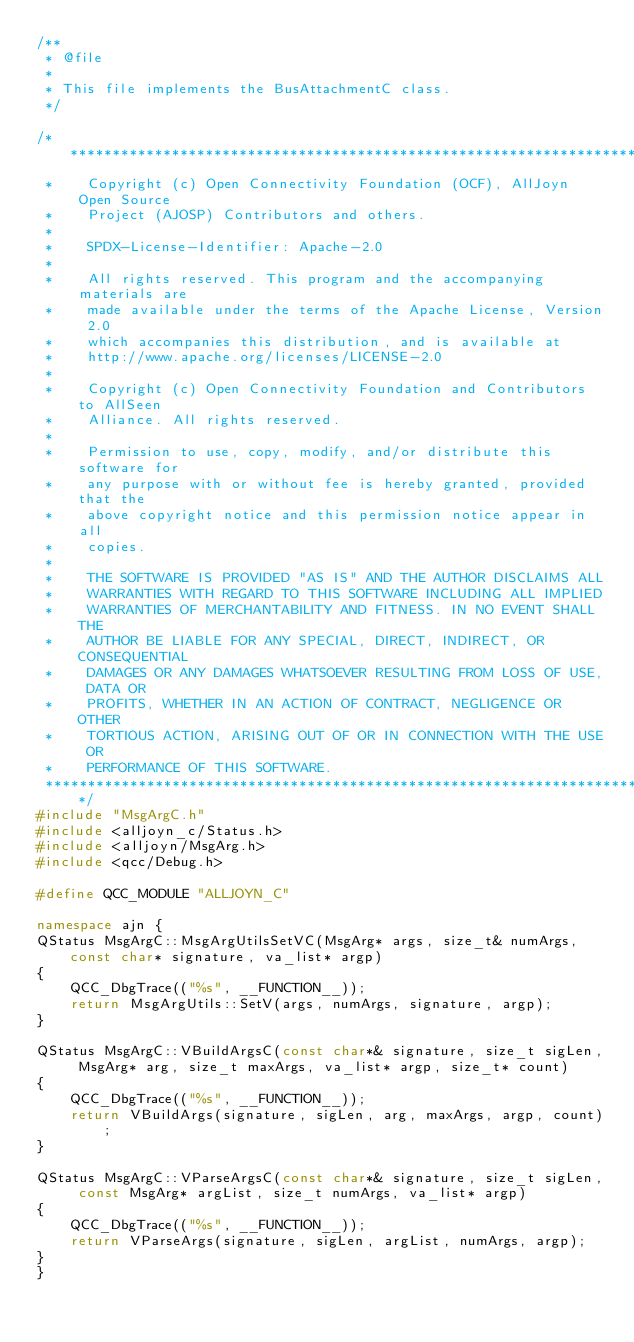<code> <loc_0><loc_0><loc_500><loc_500><_C++_>/**
 * @file
 *
 * This file implements the BusAttachmentC class.
 */

/******************************************************************************
 *    Copyright (c) Open Connectivity Foundation (OCF), AllJoyn Open Source
 *    Project (AJOSP) Contributors and others.
 *
 *    SPDX-License-Identifier: Apache-2.0
 *
 *    All rights reserved. This program and the accompanying materials are
 *    made available under the terms of the Apache License, Version 2.0
 *    which accompanies this distribution, and is available at
 *    http://www.apache.org/licenses/LICENSE-2.0
 *
 *    Copyright (c) Open Connectivity Foundation and Contributors to AllSeen
 *    Alliance. All rights reserved.
 *
 *    Permission to use, copy, modify, and/or distribute this software for
 *    any purpose with or without fee is hereby granted, provided that the
 *    above copyright notice and this permission notice appear in all
 *    copies.
 *
 *    THE SOFTWARE IS PROVIDED "AS IS" AND THE AUTHOR DISCLAIMS ALL
 *    WARRANTIES WITH REGARD TO THIS SOFTWARE INCLUDING ALL IMPLIED
 *    WARRANTIES OF MERCHANTABILITY AND FITNESS. IN NO EVENT SHALL THE
 *    AUTHOR BE LIABLE FOR ANY SPECIAL, DIRECT, INDIRECT, OR CONSEQUENTIAL
 *    DAMAGES OR ANY DAMAGES WHATSOEVER RESULTING FROM LOSS OF USE, DATA OR
 *    PROFITS, WHETHER IN AN ACTION OF CONTRACT, NEGLIGENCE OR OTHER
 *    TORTIOUS ACTION, ARISING OUT OF OR IN CONNECTION WITH THE USE OR
 *    PERFORMANCE OF THIS SOFTWARE.
 ******************************************************************************/
#include "MsgArgC.h"
#include <alljoyn_c/Status.h>
#include <alljoyn/MsgArg.h>
#include <qcc/Debug.h>

#define QCC_MODULE "ALLJOYN_C"

namespace ajn {
QStatus MsgArgC::MsgArgUtilsSetVC(MsgArg* args, size_t& numArgs, const char* signature, va_list* argp)
{
    QCC_DbgTrace(("%s", __FUNCTION__));
    return MsgArgUtils::SetV(args, numArgs, signature, argp);
}

QStatus MsgArgC::VBuildArgsC(const char*& signature, size_t sigLen, MsgArg* arg, size_t maxArgs, va_list* argp, size_t* count)
{
    QCC_DbgTrace(("%s", __FUNCTION__));
    return VBuildArgs(signature, sigLen, arg, maxArgs, argp, count);
}

QStatus MsgArgC::VParseArgsC(const char*& signature, size_t sigLen, const MsgArg* argList, size_t numArgs, va_list* argp)
{
    QCC_DbgTrace(("%s", __FUNCTION__));
    return VParseArgs(signature, sigLen, argList, numArgs, argp);
}
}
</code> 